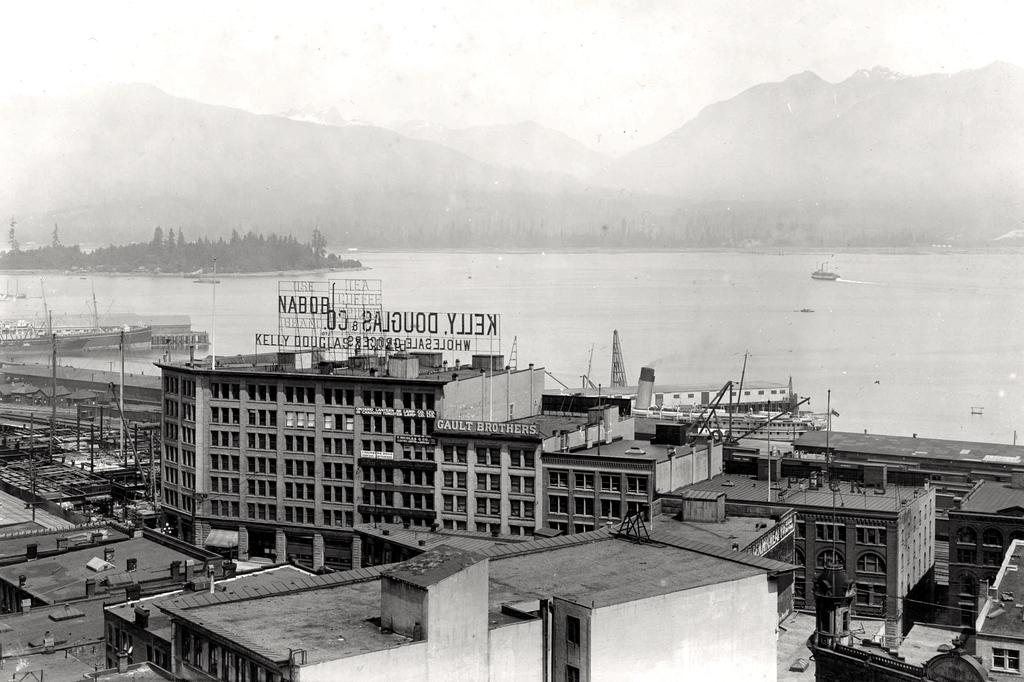What type of structures are present in the image? There are many buildings in the image. Can you describe the water feature in the image? There is a ship in a river in the image. What can be seen in the distance in the image? Hills are visible in the background of the image. What color scheme is used in the image? The image is in black and white color. What is the size of the yoke in the image? There is no yoke present in the image. What impulse drives the ship in the image? The image does not provide information about the ship's movement or the impulse driving it. 